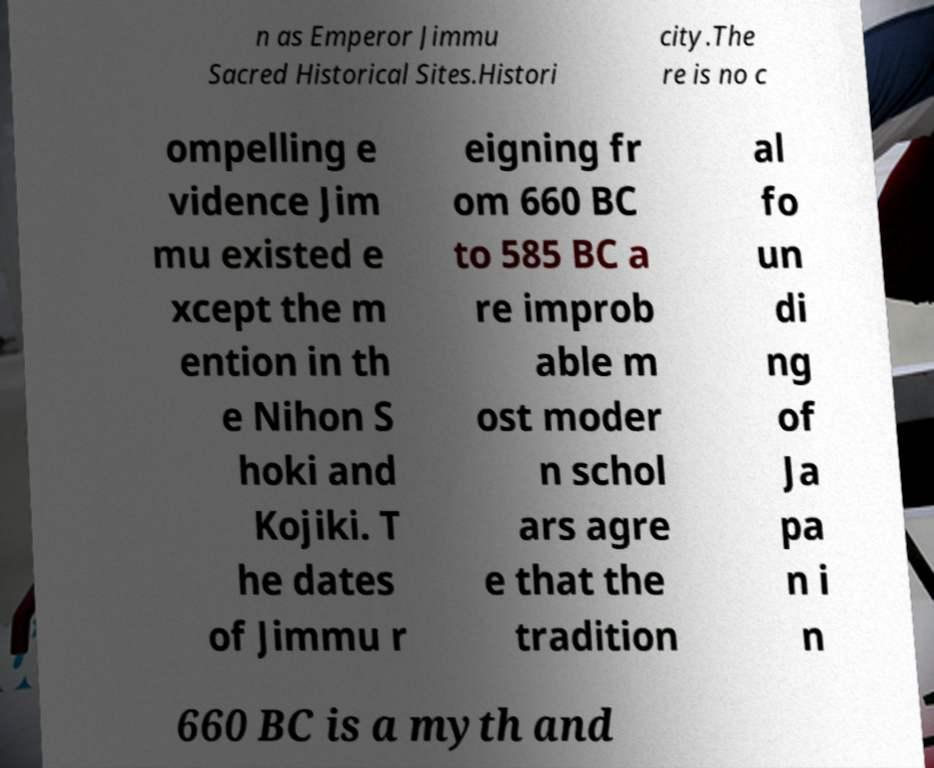Please read and relay the text visible in this image. What does it say? n as Emperor Jimmu Sacred Historical Sites.Histori city.The re is no c ompelling e vidence Jim mu existed e xcept the m ention in th e Nihon S hoki and Kojiki. T he dates of Jimmu r eigning fr om 660 BC to 585 BC a re improb able m ost moder n schol ars agre e that the tradition al fo un di ng of Ja pa n i n 660 BC is a myth and 